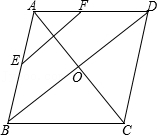What types of mathematical proofs or concepts could be demonstrated using this diagram? This diagram is suitable for demonstrating several mathematical concepts, including the Midpoint Theorem, which states that the segment joining the midpoints of two sides of a triangle is parallel to the third side and half as long. Also, the properties of perpendicular bisectors in rhombuses, symmetry in geometry, and the application of Pythagorean Theorem in special quadrilaterals can be explored using this setup. 